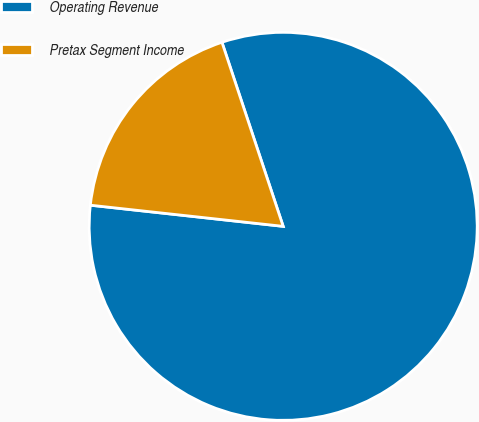Convert chart. <chart><loc_0><loc_0><loc_500><loc_500><pie_chart><fcel>Operating Revenue<fcel>Pretax Segment Income<nl><fcel>81.85%<fcel>18.15%<nl></chart> 